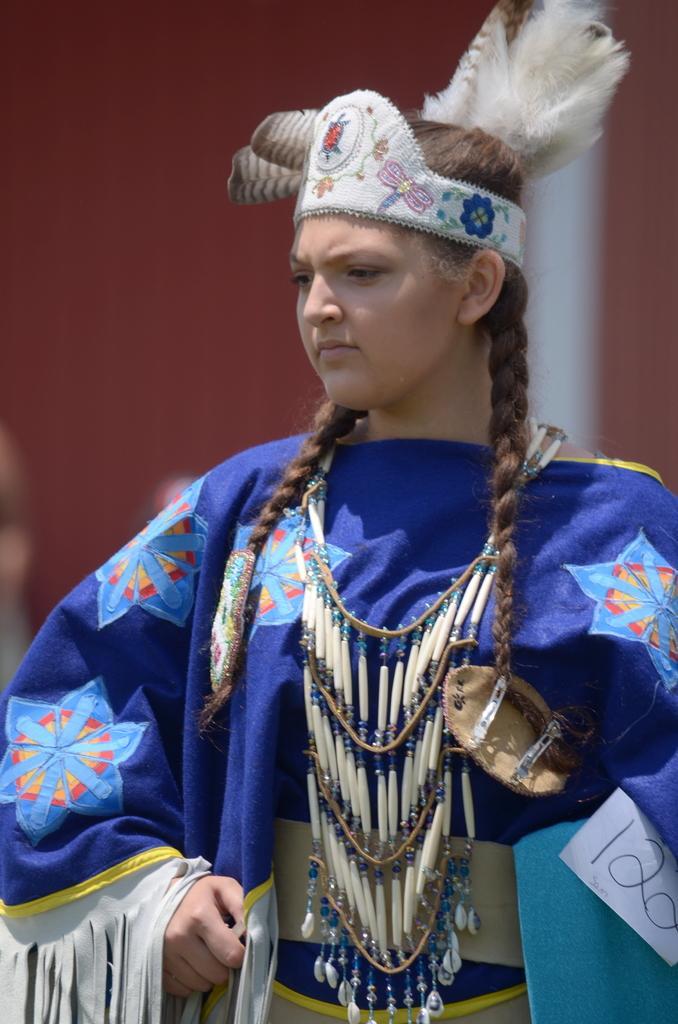Please provide a concise description of this image. In this picture there is a girl wearing a traditional blue color dress, standing in the front and looking on the left side. Behind there is a red color blur background. 